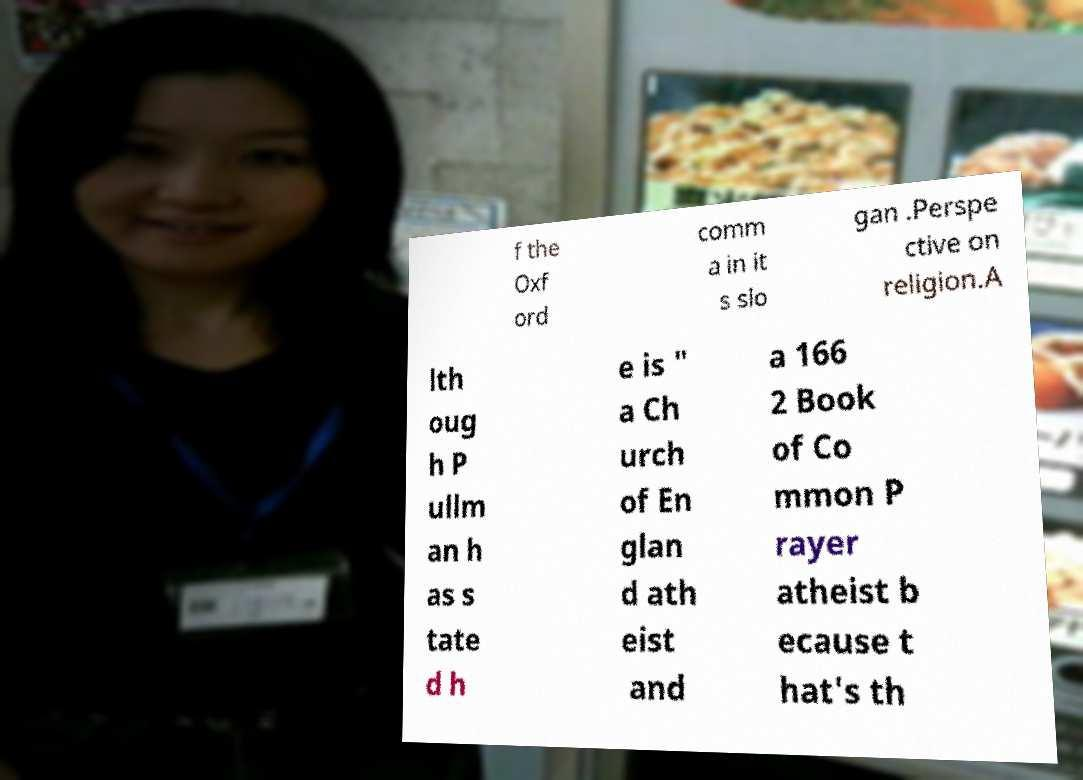What messages or text are displayed in this image? I need them in a readable, typed format. f the Oxf ord comm a in it s slo gan .Perspe ctive on religion.A lth oug h P ullm an h as s tate d h e is " a Ch urch of En glan d ath eist and a 166 2 Book of Co mmon P rayer atheist b ecause t hat's th 